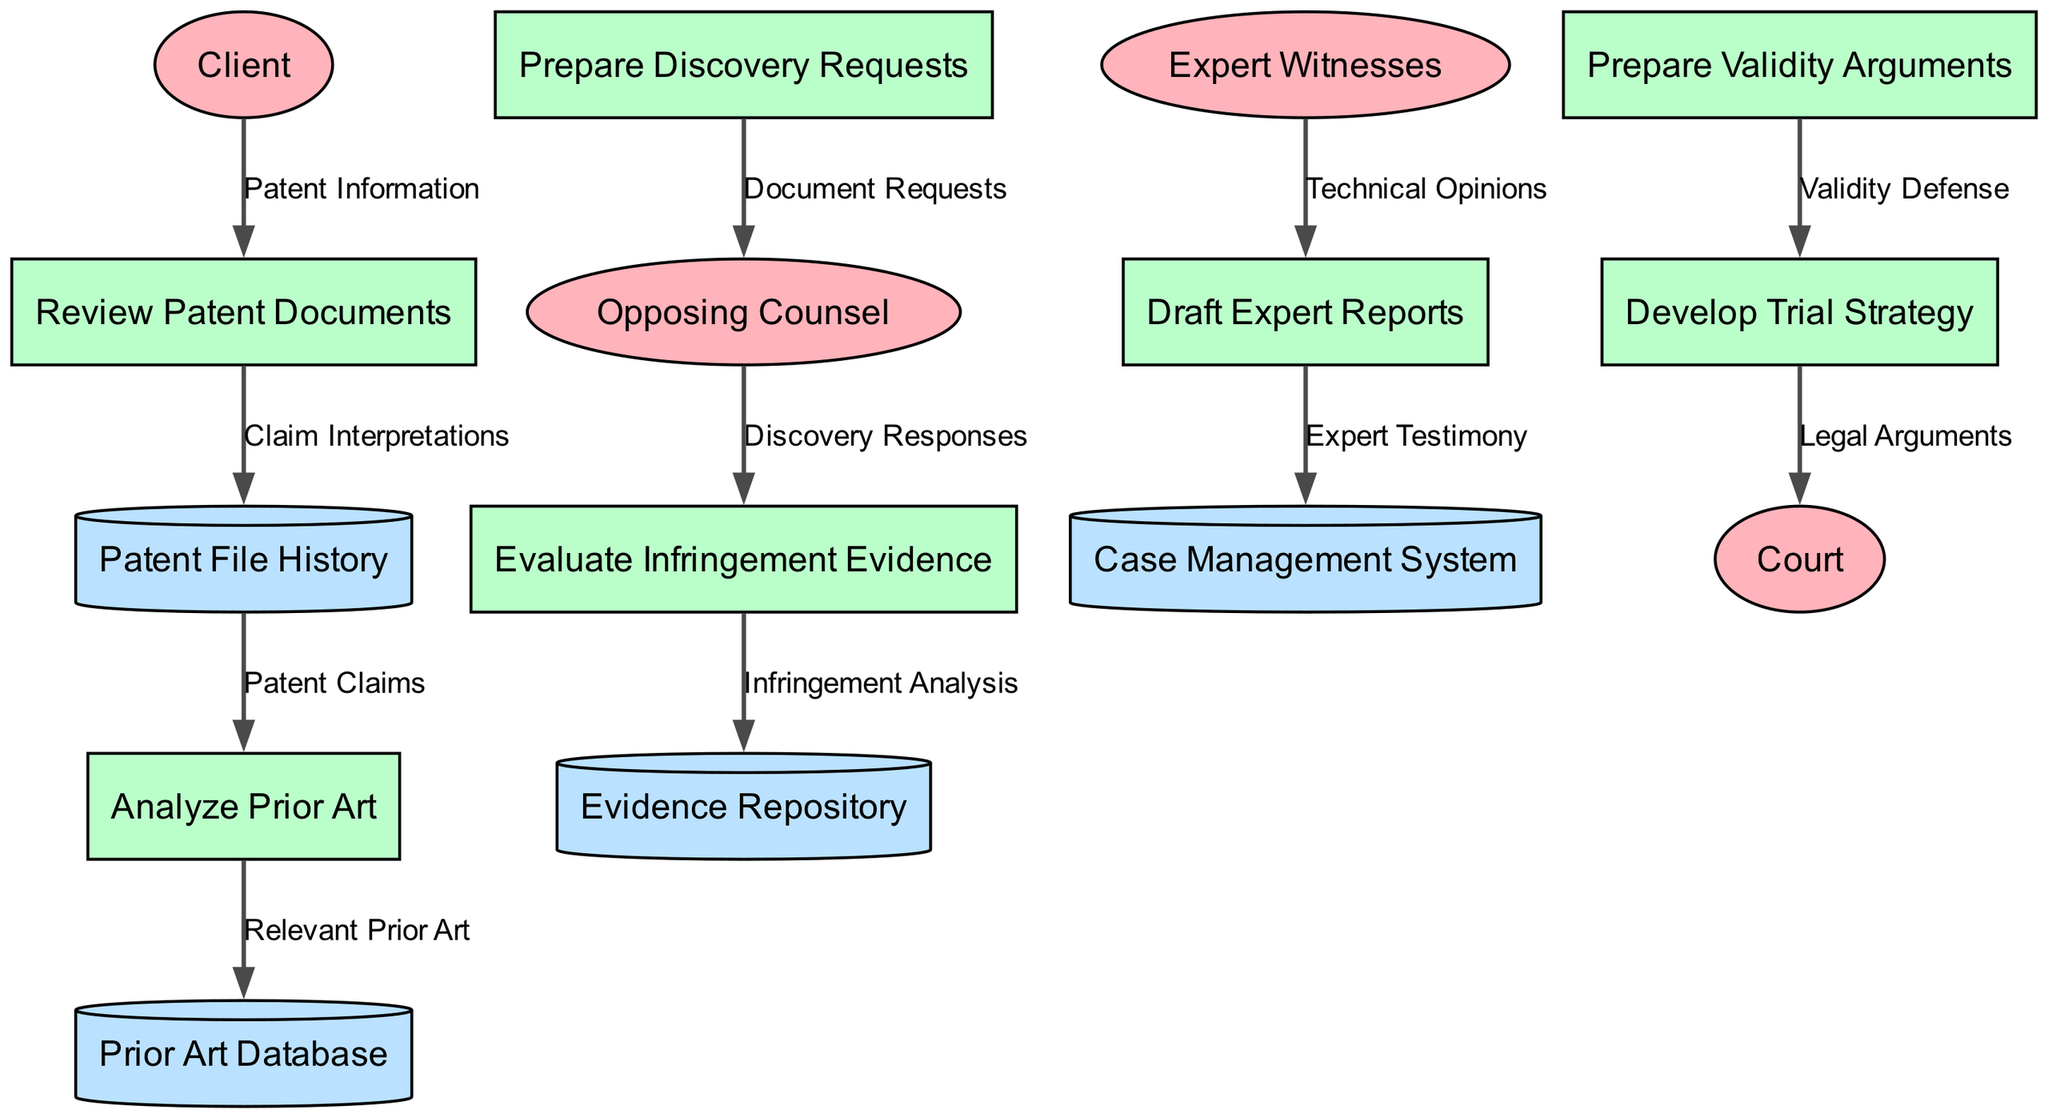What are the external entities in this data flow diagram? The diagram includes four external entities: Client, Opposing Counsel, Expert Witnesses, and Court. These were identified in the section dedicated to external entities.
Answer: Client, Opposing Counsel, Expert Witnesses, Court How many processes are depicted in the diagram? The number of processes can be easily counted from the list provided. There are seven distinct processes described in the data flow diagram.
Answer: Seven What type of information flows from the Client to the "Review Patent Documents"? The data flow from the Client to "Review Patent Documents" is labeled "Patent Information". This label indicates the specific type of information being provided.
Answer: Patent Information Which process receives data from "Analyze Prior Art"? The process that receives data from "Analyze Prior Art" is "Prior Art Database". This can be inferred by following the directed flow from "Analyze Prior Art" to "Prior Art Database".
Answer: Prior Art Database What is the flow that transmits "Technical Opinions"? "Technical Opinions" flow from "Expert Witnesses" to "Draft Expert Reports". This can be traced directly from the respective nodes in the diagram.
Answer: Draft Expert Reports When does the "Develop Trial Strategy" occur? "Develop Trial Strategy" occurs after "Prepare Validity Arguments". This sequence can be followed by analyzing the directed flow between the two processes as illustrated in the diagram.
Answer: After "Prepare Validity Arguments" What type of data is sent to the Court? The type of data sent to the Court is "Legal Arguments". This is indicated by the final flow that directs information from "Develop Trial Strategy" to "Court".
Answer: Legal Arguments Which data store contains "Infringement Analysis"? The "Evidence Repository" is where "Infringement Analysis" is stored, as shown in the directed flow from "Evaluate Infringement Evidence" to "Evidence Repository".
Answer: Evidence Repository How many edges connect to the process "Prepare Discovery Requests"? There is one edge connecting to the process "Prepare Discovery Requests", which indicates there is only one incoming flow in the diagram represented by "Document Requests" from "Opposing Counsel".
Answer: One 